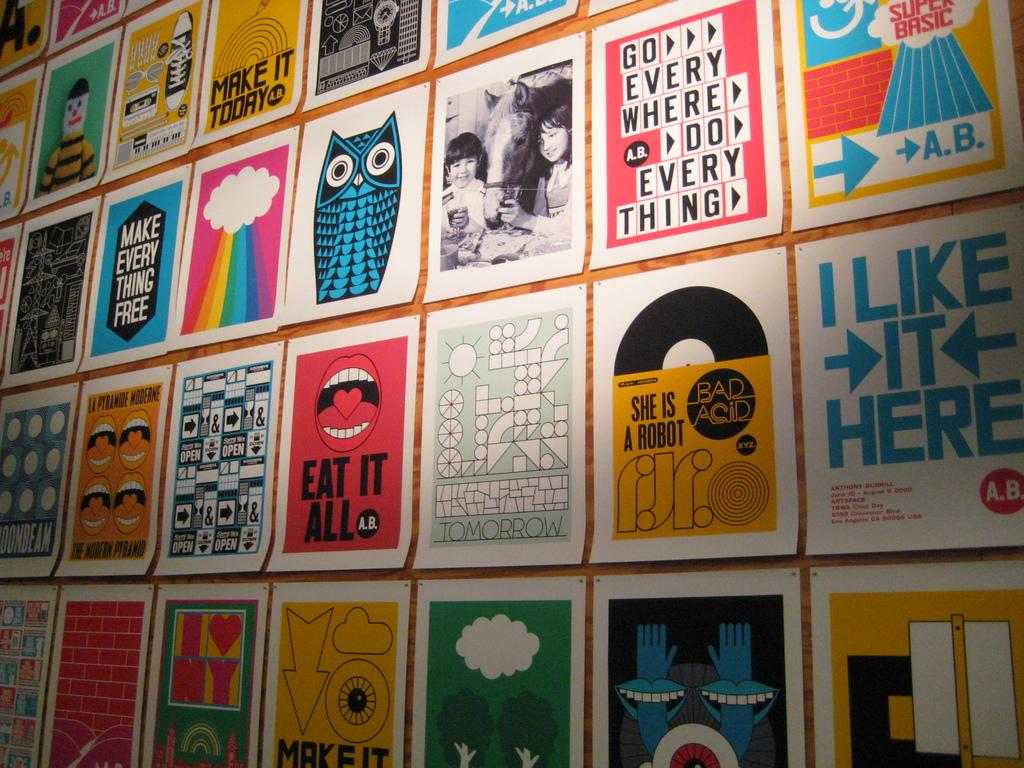<image>
Relay a brief, clear account of the picture shown. A wall full of posters, one of which says I Like it Here. 